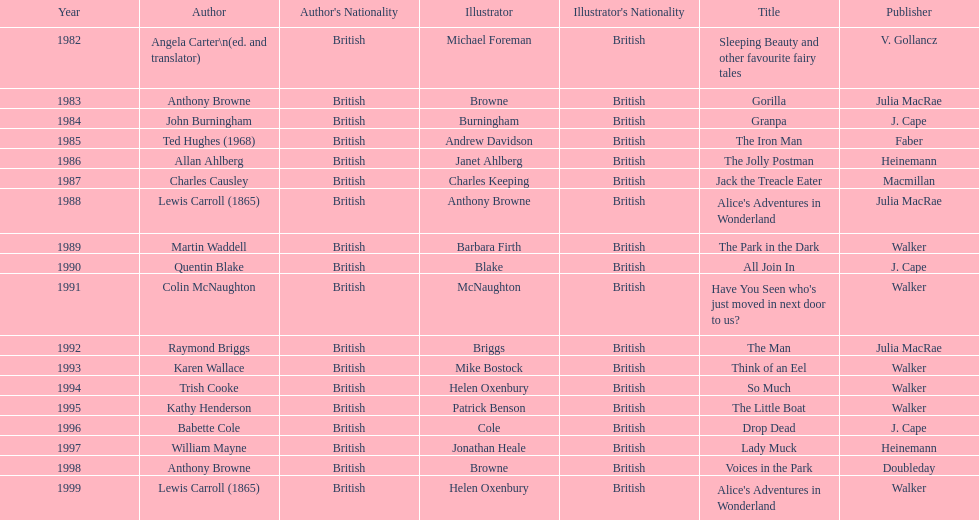Which title was after the year 1991 but before the year 1993? The Man. 